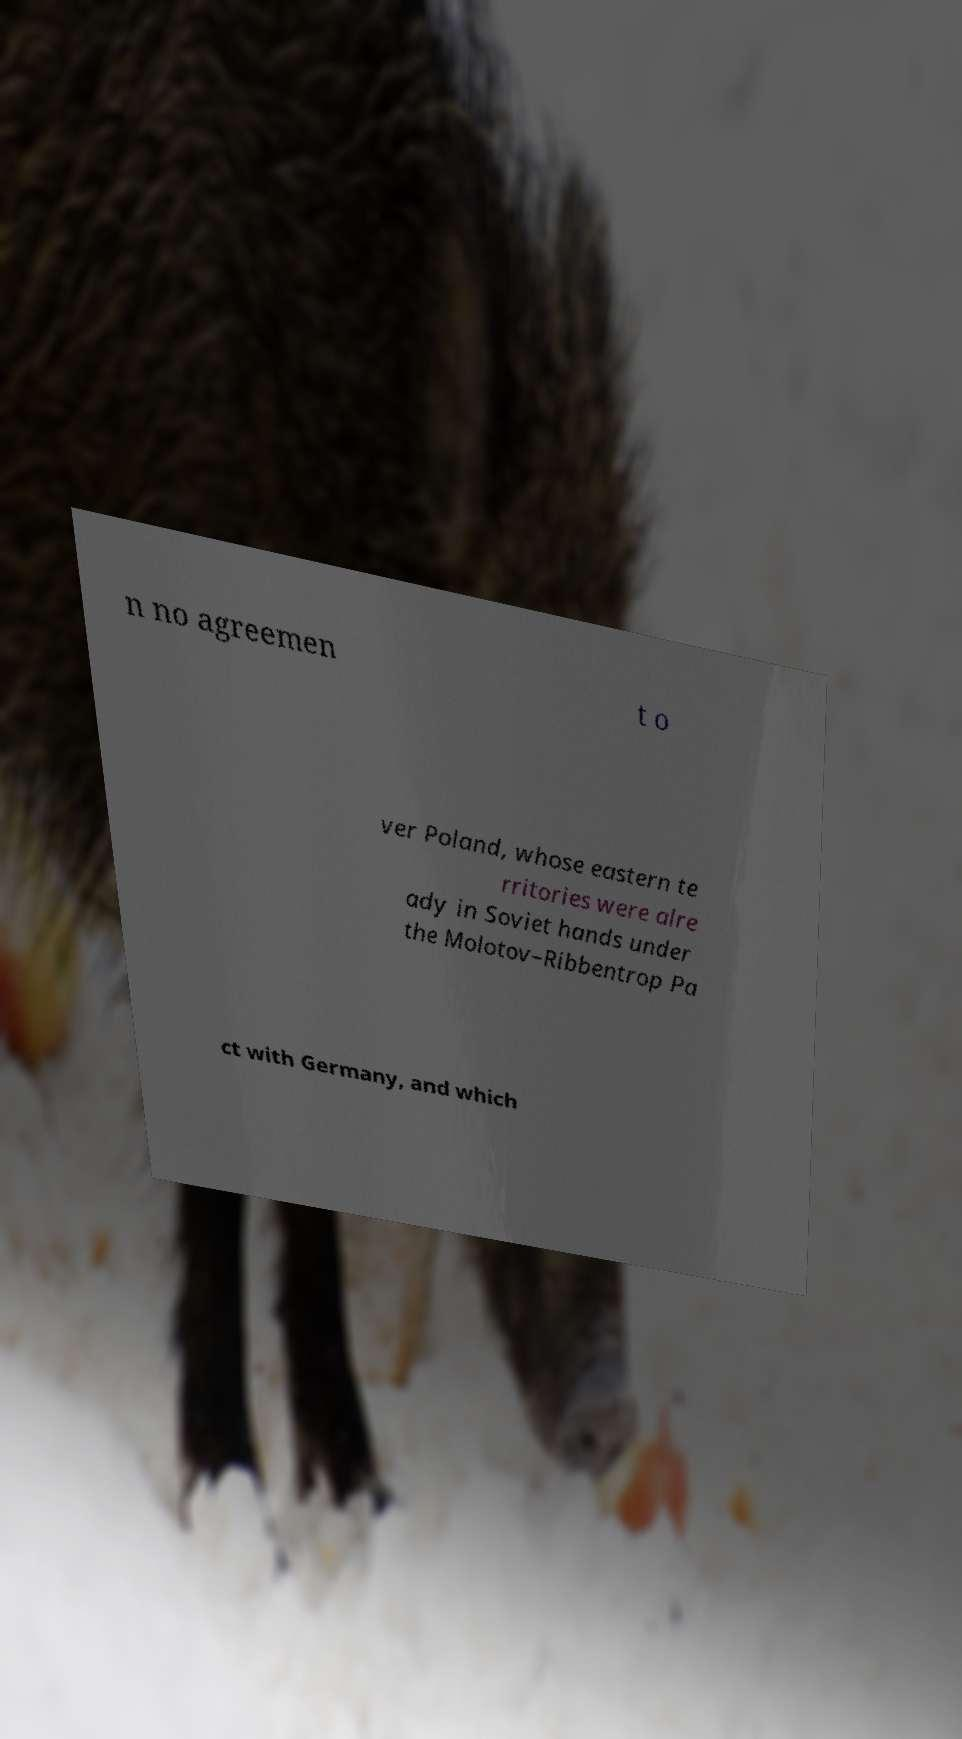Please read and relay the text visible in this image. What does it say? n no agreemen t o ver Poland, whose eastern te rritories were alre ady in Soviet hands under the Molotov–Ribbentrop Pa ct with Germany, and which 